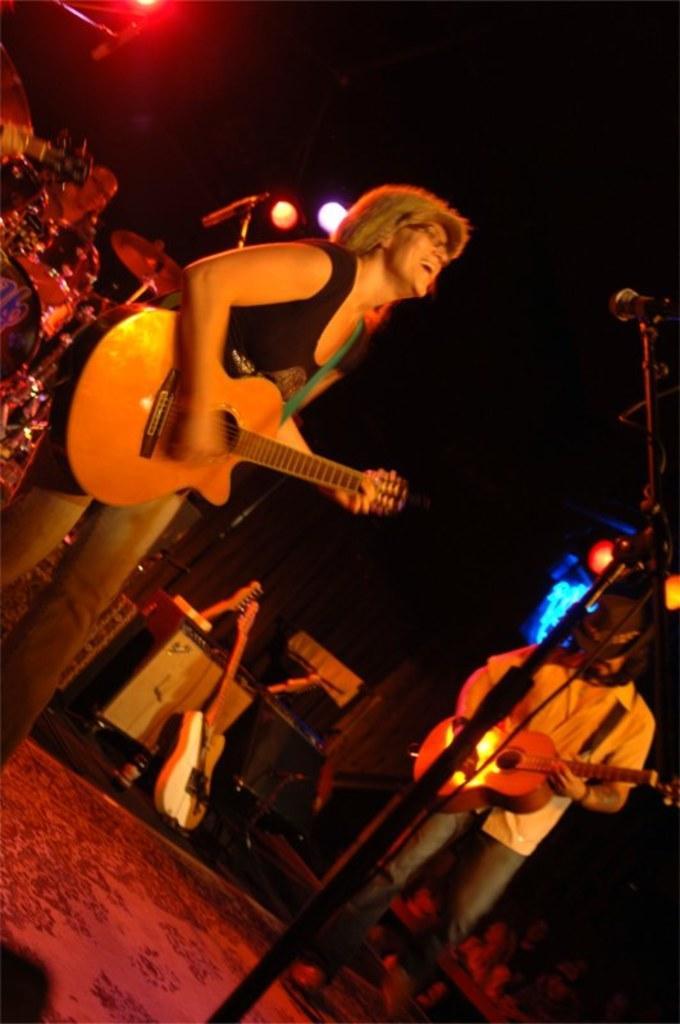Please provide a concise description of this image. This picture is clicked in a musical concert. Woman in black t-shirt is holding guitar in her hands and playing it and she is even singing. Man on the right corner who is wearing white shirt is also holding guitar in his hands and playing it. In front of the picture, we see microphone and behind them, we see guitar placed on the table. 